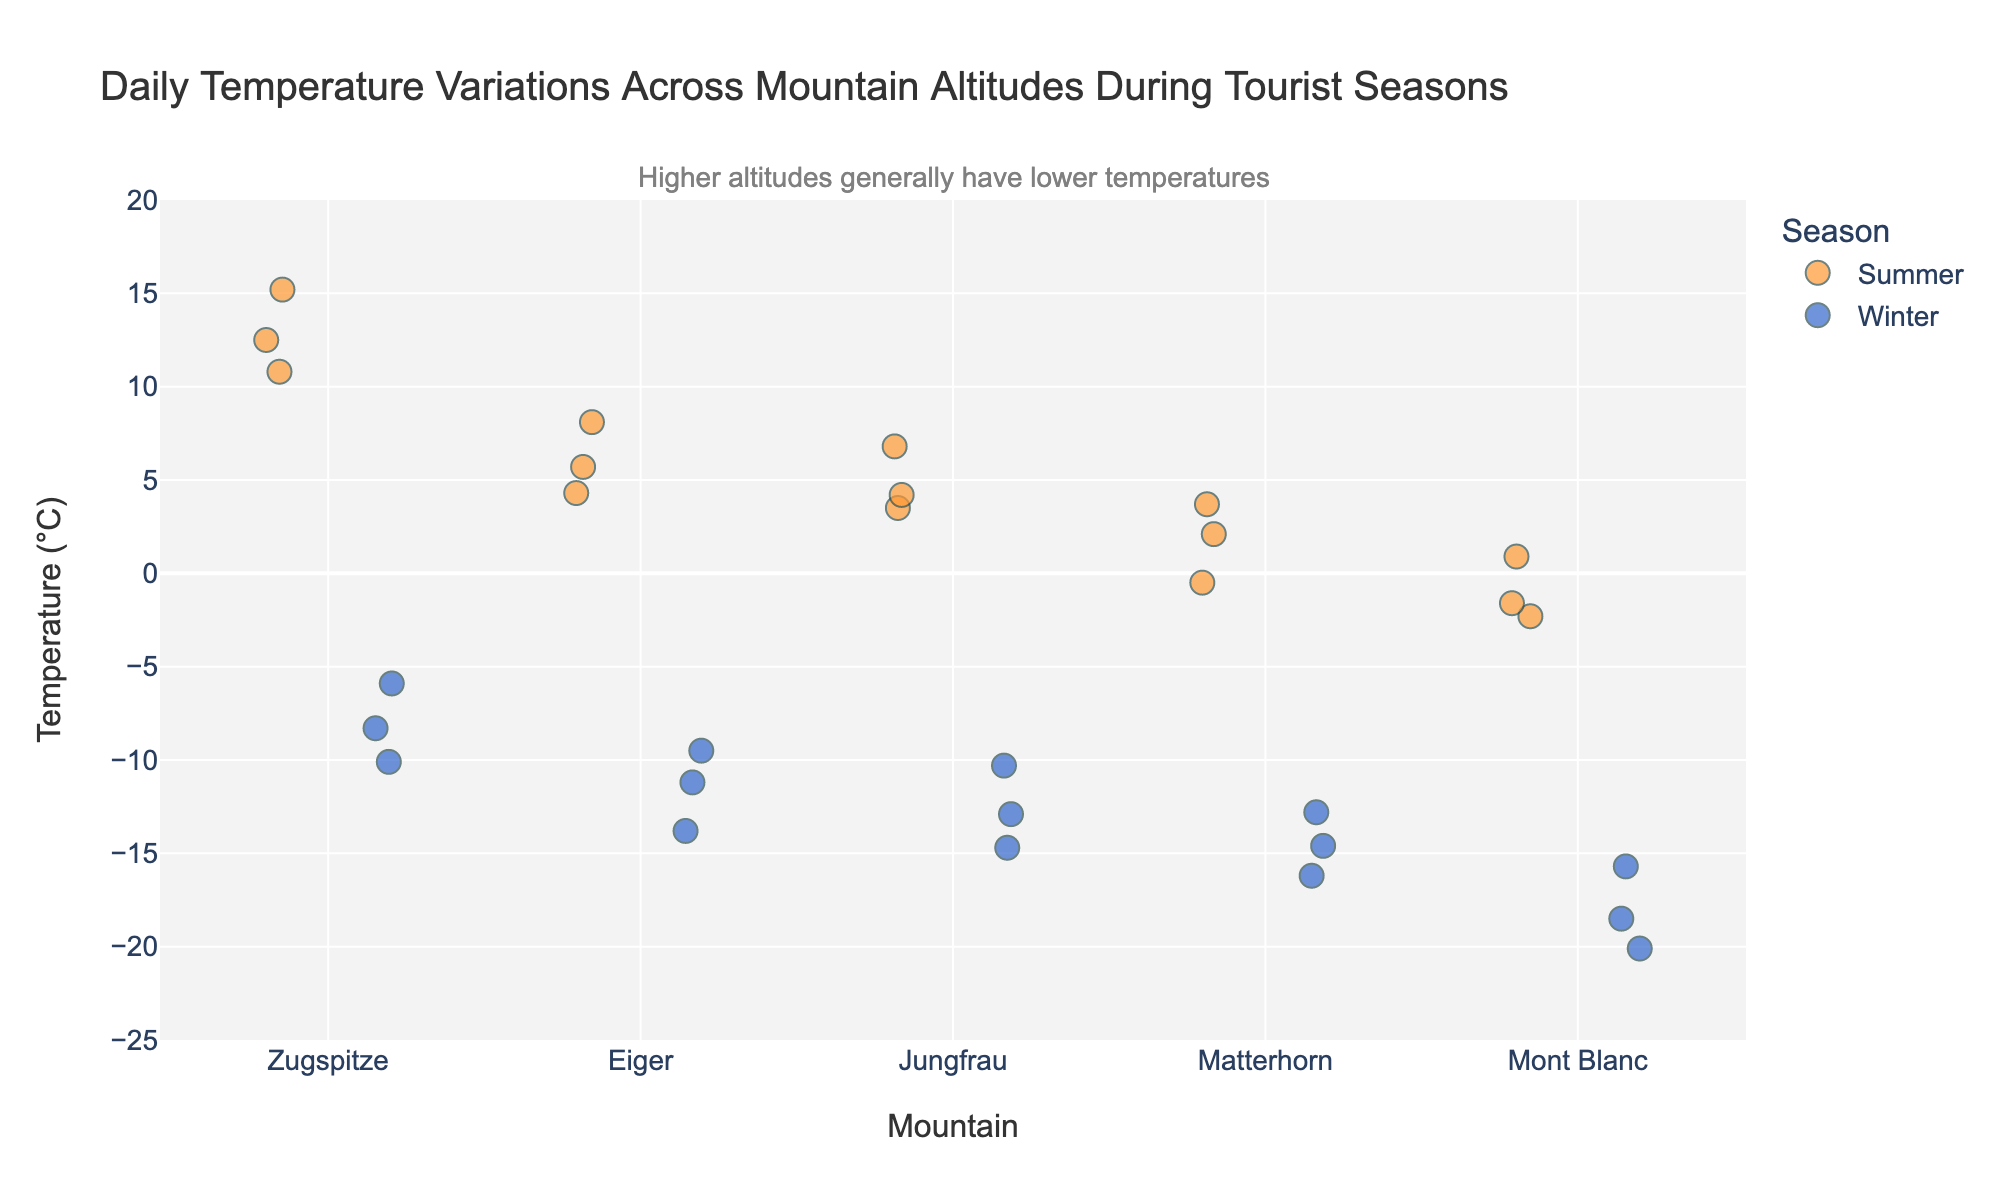What is the title of the plot? The title is located at the top center of the plot and clearly states the main focus. It reads "Daily Temperature Variations Across Mountain Altitudes During Tourist Seasons".
Answer: Daily Temperature Variations Across Mountain Altitudes During Tourist Seasons Which seasons are represented by different colors in the plot? The color legend indicates that "Summer" is represented by an orange color, while "Winter" is represented by a blue color.
Answer: Summer and Winter What range of temperatures can be observed on Mont Blanc during Winter? By evaluating the data available for Mont Blanc in Winter, the plot shows that the temperature ranges from approximately -20.1°C to -15.7°C.
Answer: -20.1°C to -15.7°C Which mountain shows the highest temperature during Summer? By observing the strip plot for Summer data, the highest temperature recorded is around 15.2°C for Zugspitze.
Answer: Zugspitze How does the temperature variation between Summer and Winter for Matterhorn compare? By comparing the spread of data points for Matterhorn in both seasons, we observe that Summer temperatures range from -0.5°C to 3.7°C while Winter temperatures are much lower, ranging from -16.2°C to -12.8°C.
Answer: Summer: -0.5°C to 3.7°C, Winter: -16.2°C to -12.8°C On average, is the temperature higher in Summer or Winter for Eiger? Observing the color-coded temperatures for Eiger, Summer temperatures range from 4.3°C to 8.1°C, while Winter temperatures range from -13.8°C to -9.5°C. It is evident that the average temperature in Summer is higher than in Winter.
Answer: Summer Which mountain has the greatest temperature variation in Winter? The temperature variation can be judged by observing the spread of data points in Winter for each mountain. Mont Blanc shows the largest spread from -20.1°C to -15.7°C.
Answer: Mont Blanc What is the general trend of temperature with increasing altitude? The annotation in the plot already hints at the trend. Higher altitudes generally correlate with lower temperatures, which is evident as the highest altitude (Mont Blanc) has the lowest temperatures.
Answer: Temperatures decrease with increasing altitude Is there any overlap in temperature ranges between Summer and Winter for any mountain? Observing the plot carefully, we notice that there are no overlaps in temperature ranges for Summer and Winter within any single mountain.
Answer: No 